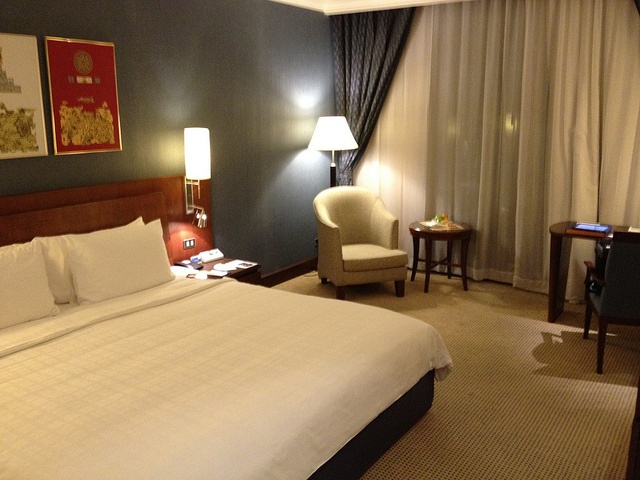Describe the objects in this image and their specific colors. I can see bed in black and tan tones, chair in black, maroon, khaki, and tan tones, and chair in black, maroon, and gray tones in this image. 